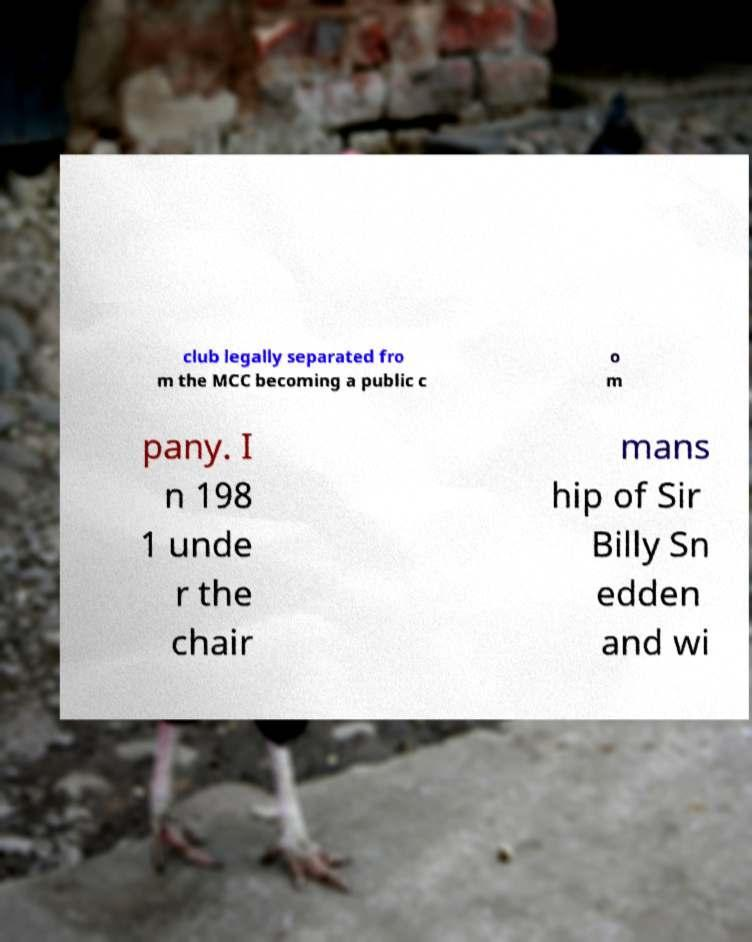For documentation purposes, I need the text within this image transcribed. Could you provide that? club legally separated fro m the MCC becoming a public c o m pany. I n 198 1 unde r the chair mans hip of Sir Billy Sn edden and wi 